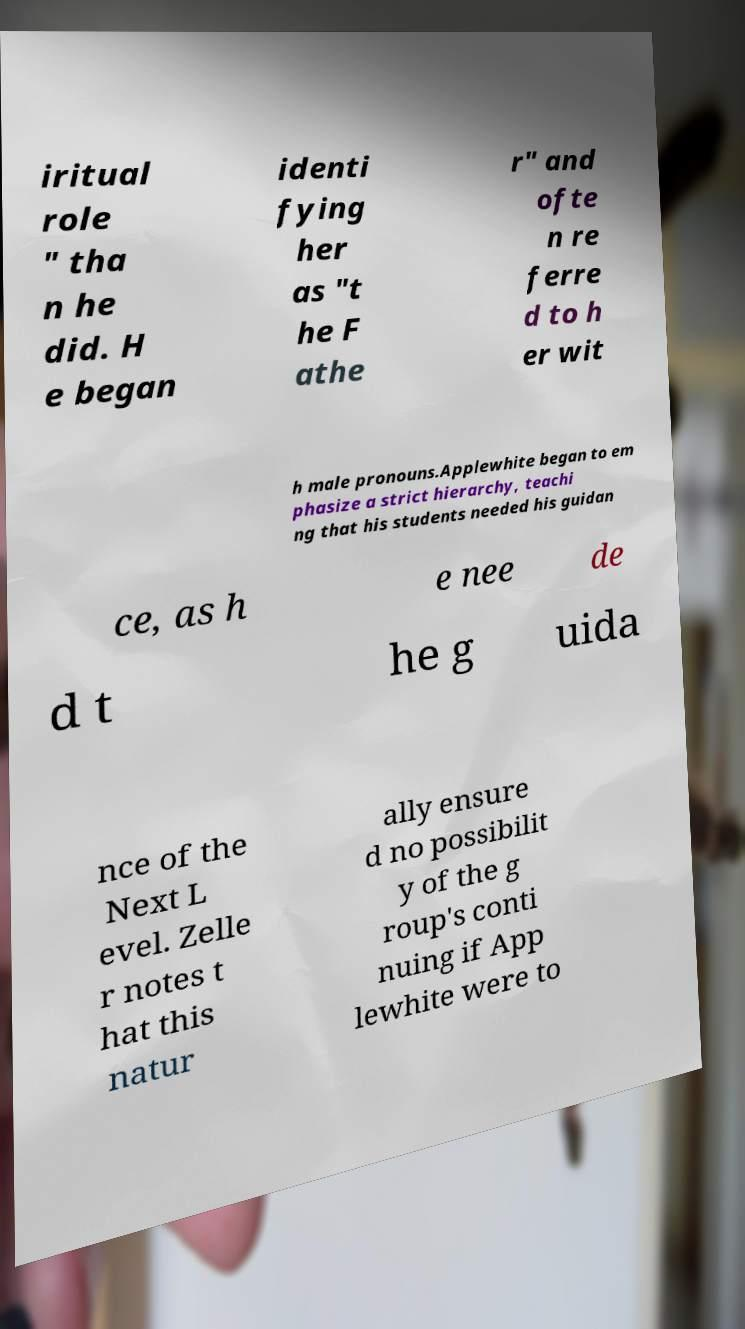Please read and relay the text visible in this image. What does it say? iritual role " tha n he did. H e began identi fying her as "t he F athe r" and ofte n re ferre d to h er wit h male pronouns.Applewhite began to em phasize a strict hierarchy, teachi ng that his students needed his guidan ce, as h e nee de d t he g uida nce of the Next L evel. Zelle r notes t hat this natur ally ensure d no possibilit y of the g roup's conti nuing if App lewhite were to 